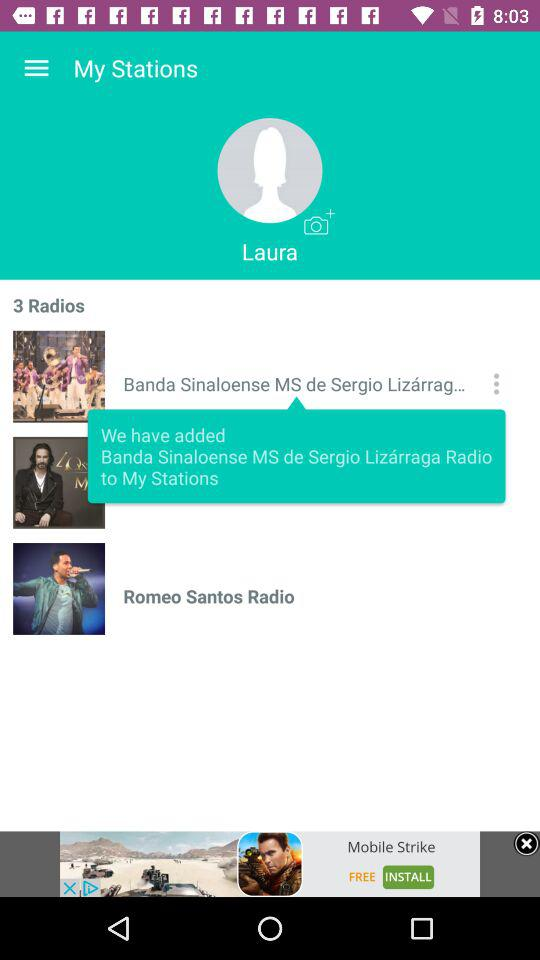What's the total number of radios? The total number of radios is 3. 